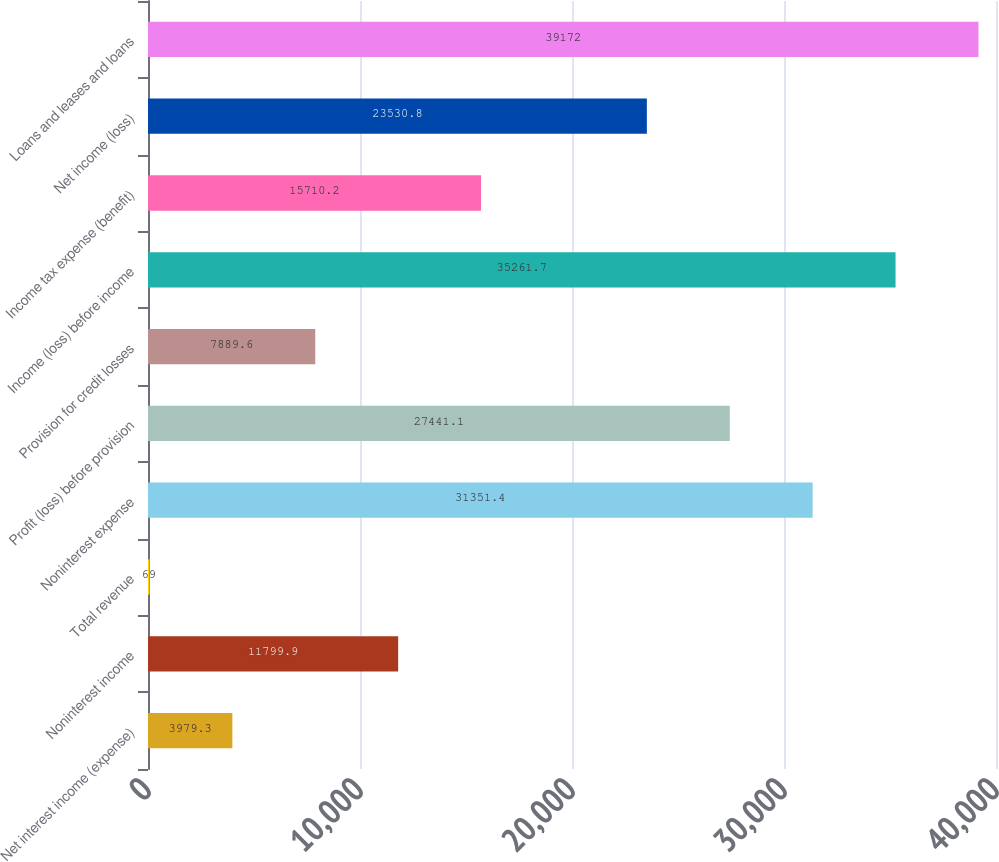Convert chart. <chart><loc_0><loc_0><loc_500><loc_500><bar_chart><fcel>Net interest income (expense)<fcel>Noninterest income<fcel>Total revenue<fcel>Noninterest expense<fcel>Profit (loss) before provision<fcel>Provision for credit losses<fcel>Income (loss) before income<fcel>Income tax expense (benefit)<fcel>Net income (loss)<fcel>Loans and leases and loans<nl><fcel>3979.3<fcel>11799.9<fcel>69<fcel>31351.4<fcel>27441.1<fcel>7889.6<fcel>35261.7<fcel>15710.2<fcel>23530.8<fcel>39172<nl></chart> 